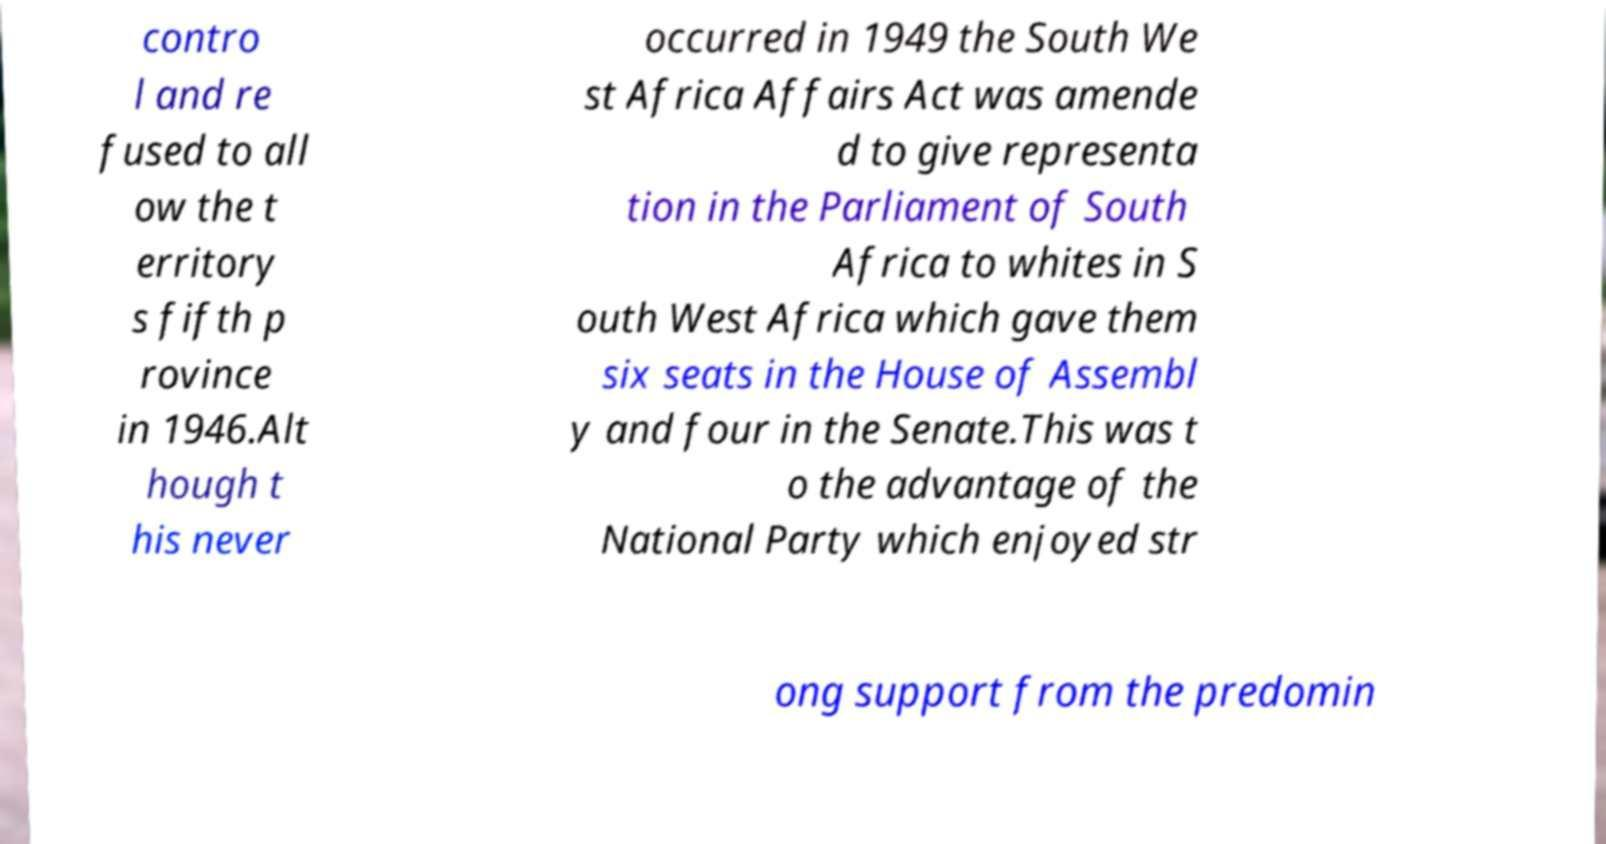Could you assist in decoding the text presented in this image and type it out clearly? contro l and re fused to all ow the t erritory s fifth p rovince in 1946.Alt hough t his never occurred in 1949 the South We st Africa Affairs Act was amende d to give representa tion in the Parliament of South Africa to whites in S outh West Africa which gave them six seats in the House of Assembl y and four in the Senate.This was t o the advantage of the National Party which enjoyed str ong support from the predomin 